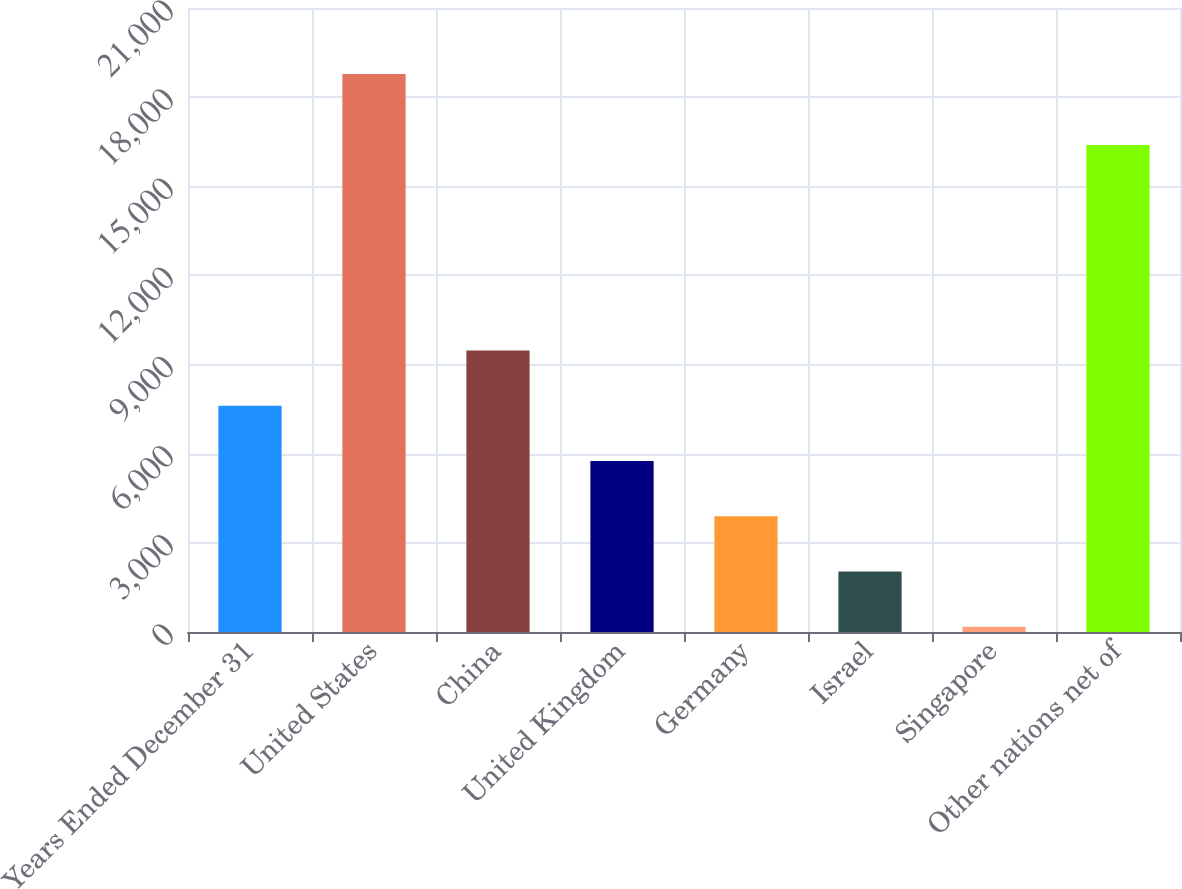Convert chart. <chart><loc_0><loc_0><loc_500><loc_500><bar_chart><fcel>Years Ended December 31<fcel>United States<fcel>China<fcel>United Kingdom<fcel>Germany<fcel>Israel<fcel>Singapore<fcel>Other nations net of<nl><fcel>7616<fcel>18776<fcel>9476<fcel>5756<fcel>3896<fcel>2036<fcel>176<fcel>16392<nl></chart> 